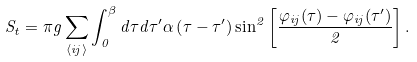<formula> <loc_0><loc_0><loc_500><loc_500>S _ { t } = \pi g \sum _ { \langle i j \rangle } \int _ { 0 } ^ { \beta } d \tau d \tau ^ { \prime } \alpha \left ( \tau - \tau ^ { \prime } \right ) \sin ^ { 2 } \left [ \frac { \varphi _ { i j } ( \tau ) - \varphi _ { i j } ( \tau ^ { \prime } ) } { 2 } \right ] .</formula> 